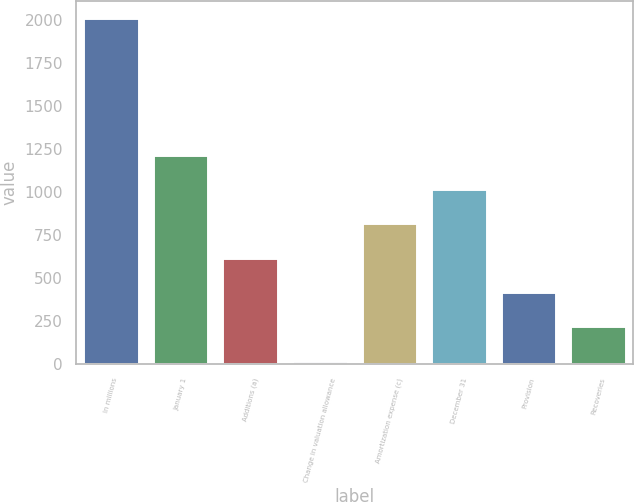Convert chart. <chart><loc_0><loc_0><loc_500><loc_500><bar_chart><fcel>In millions<fcel>January 1<fcel>Additions (a)<fcel>Change in valuation allowance<fcel>Amortization expense (c)<fcel>December 31<fcel>Provision<fcel>Recoveries<nl><fcel>2012<fcel>1215.6<fcel>618.3<fcel>21<fcel>817.4<fcel>1016.5<fcel>419.2<fcel>220.1<nl></chart> 